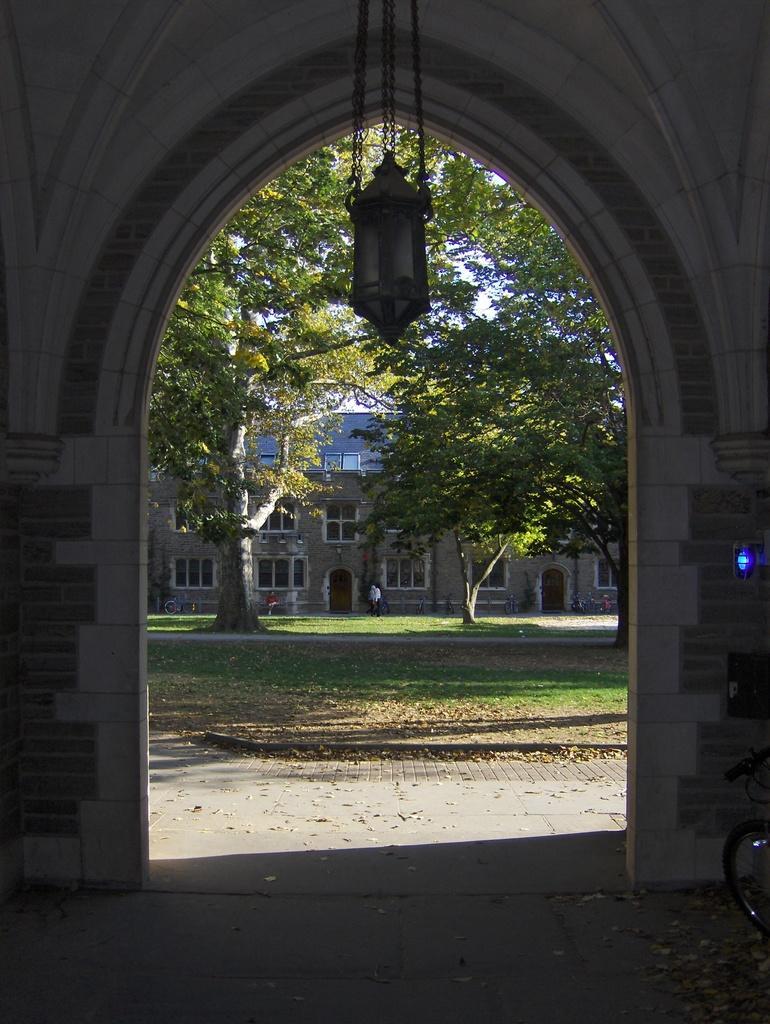In one or two sentences, can you explain what this image depicts? The picture is taken inside a building. This is an entrance. On the top there is a light. Here there is a bike. In the background there are buildings, trees. A person is standing here. On the ground there are dried leaves. 